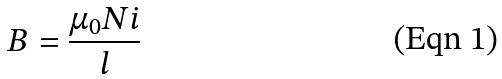<formula> <loc_0><loc_0><loc_500><loc_500>B = \frac { \mu _ { 0 } N i } { l }</formula> 